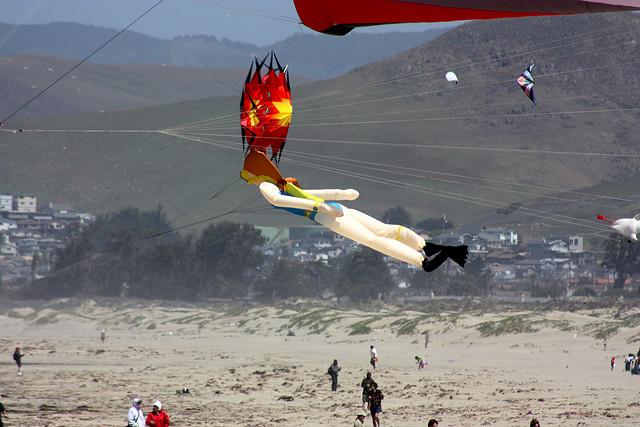Imagine you're one of the kites in this scene. What do you see and feel? As a kite soaring high above the beach, I feel the thrill of the wind tugging at my frame, guiding me through the air with ease. From this lofty vantage point, I can see the vast expanse of sand stretching out below me, dotted with people who appear like tiny figures engrossed in their activities. The other kites nearby, of varying shapes and designs, flutter and dance in the breeze, creating a colorful tapestry against the sky. Beyond the immediate beach, I see the rolling hills and the quaint town nestled at their base, houses and buildings neatly lined up. The horizon merges seamlessly with the sea, its gentle waves meeting the shore. The whole scene exudes a sense of freedom and joy, as if the entire world is celebrating this moment of aerial dance. 